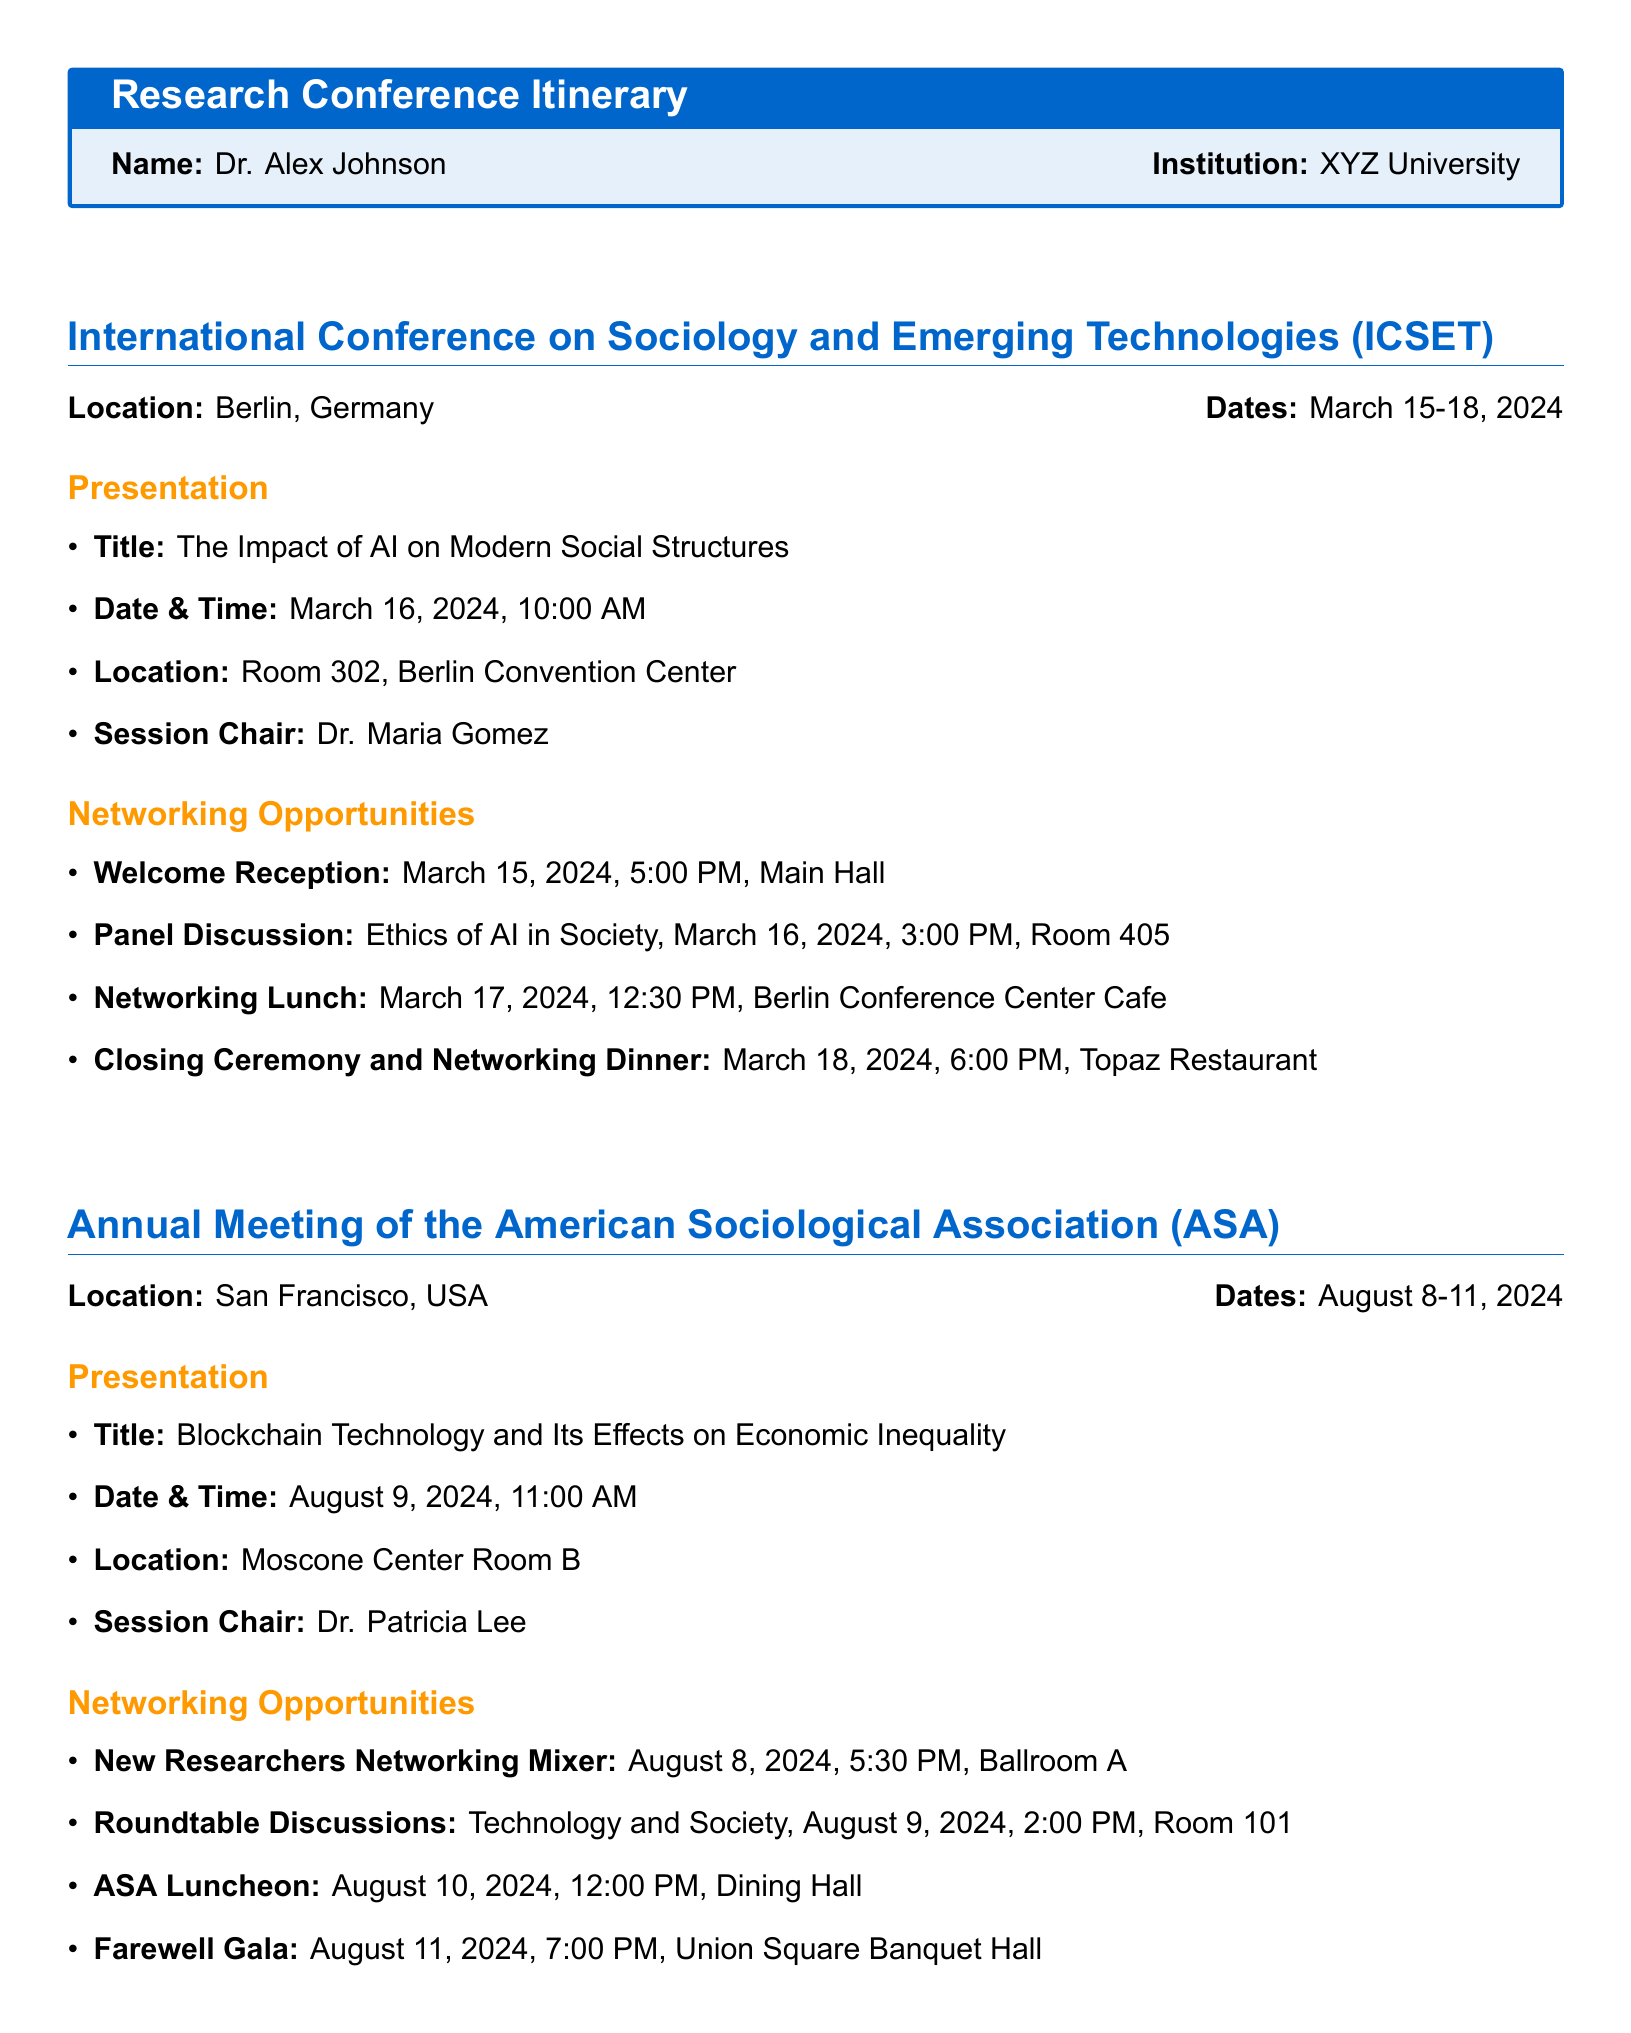What is the date of the first networking opportunity? The first networking opportunity is the Welcome Reception on March 15, 2024.
Answer: March 15, 2024 Who is the session chair for the presentation at ICSET? The session chair for the presentation "The Impact of AI on Modern Social Structures" at ICSET is Dr. Maria Gomez.
Answer: Dr. Maria Gomez What is the title of the presentation at ASA? The title of the presentation at ASA is "Blockchain Technology and Its Effects on Economic Inequality."
Answer: Blockchain Technology and Its Effects on Economic Inequality When does the Closing Ceremony and Networking Dinner take place? The Closing Ceremony and Networking Dinner is on March 18, 2024, at 6:00 PM.
Answer: March 18, 2024, 6:00 PM What is the location of the ASA Luncheon? The ASA Luncheon is held in the Dining Hall.
Answer: Dining Hall What time is the Panel Discussion at ICSET scheduled for? The Panel Discussion is scheduled for March 16, 2024, at 3:00 PM.
Answer: 3:00 PM Where will the New Researchers Networking Mixer be held? The New Researchers Networking Mixer will take place in Ballroom A.
Answer: Ballroom A How many days is the ICSET conference? The ICSET conference lasts for four days, from March 15-18, 2024.
Answer: Four days 